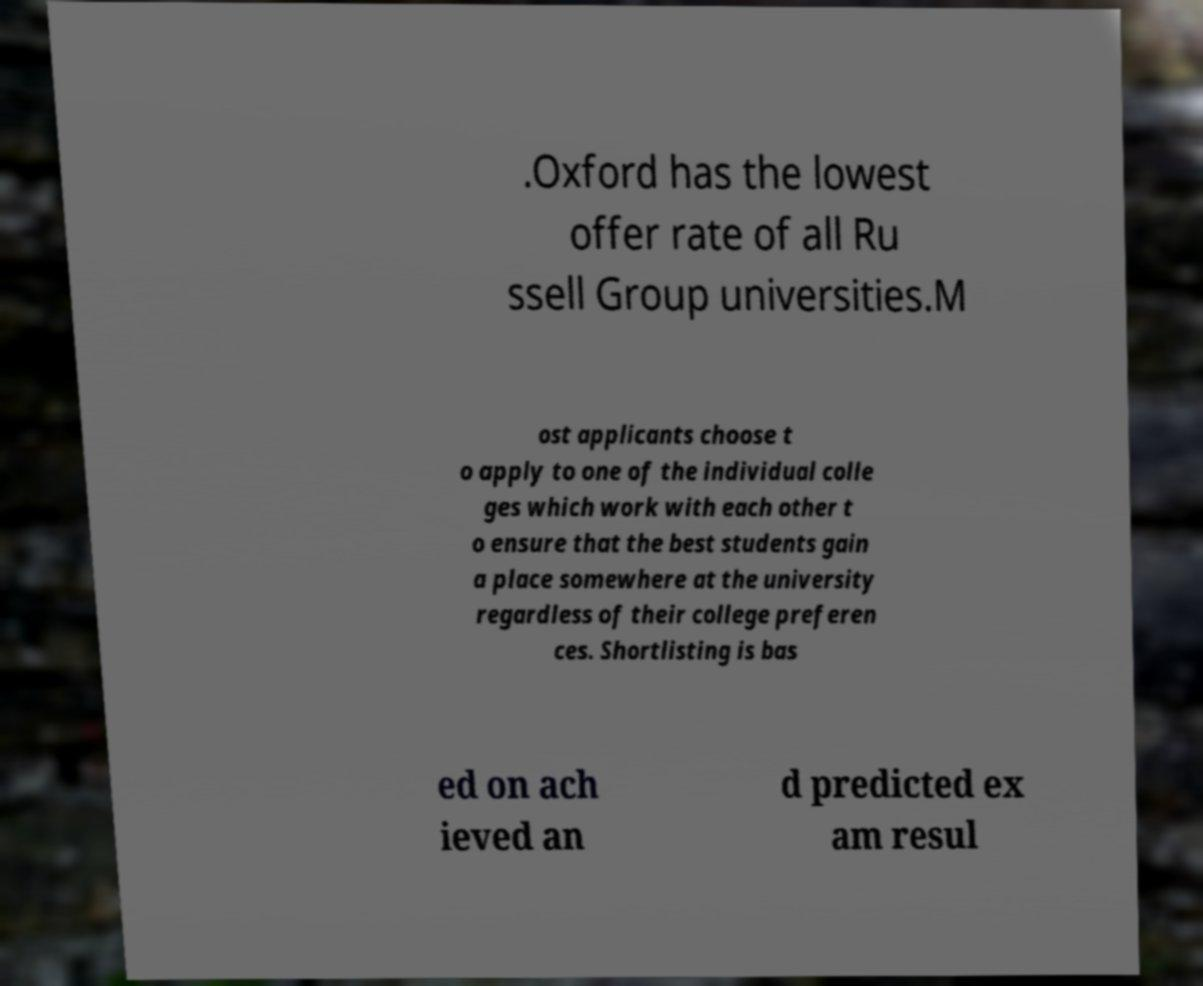What messages or text are displayed in this image? I need them in a readable, typed format. .Oxford has the lowest offer rate of all Ru ssell Group universities.M ost applicants choose t o apply to one of the individual colle ges which work with each other t o ensure that the best students gain a place somewhere at the university regardless of their college preferen ces. Shortlisting is bas ed on ach ieved an d predicted ex am resul 